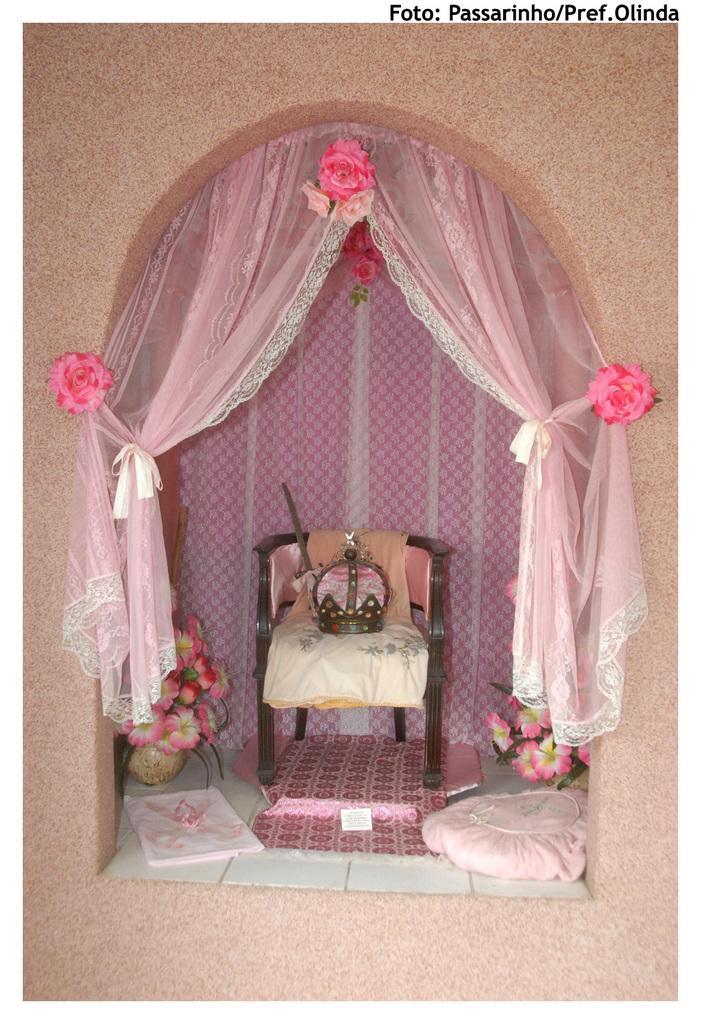In one or two sentences, can you explain what this image depicts? in this image i can see a chair. On the chair i can see a cloth and basket. At the back side there is a pink cloth. There is a flower pot on the floor. In front there is a pink curtain with roses. 